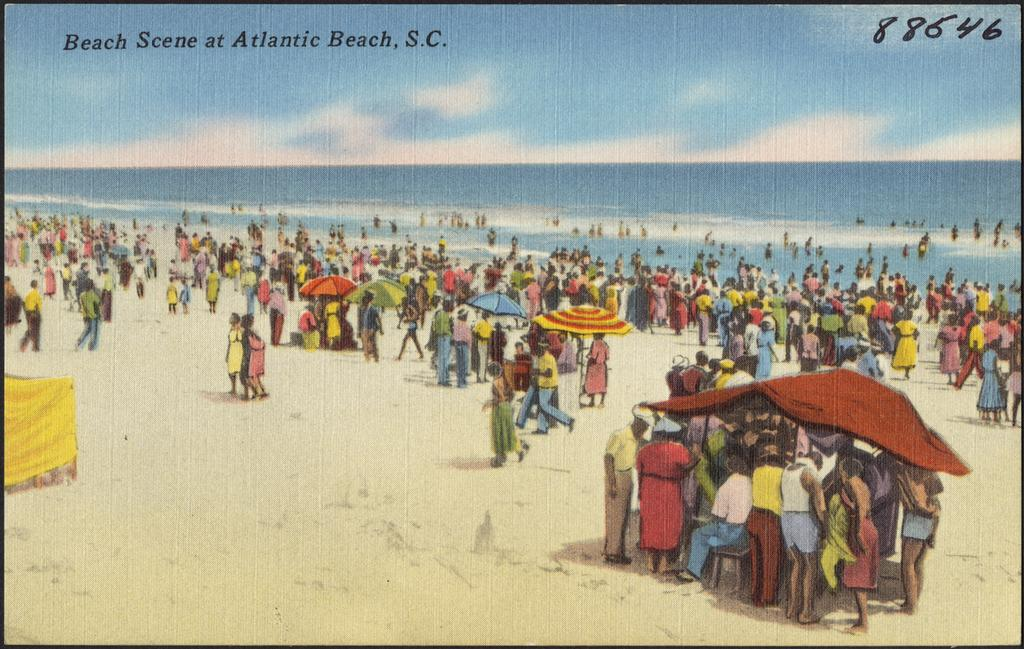<image>
Present a compact description of the photo's key features. An old postcard of Atlantic Beach, S.C. with the number88646 handwritten on it. 